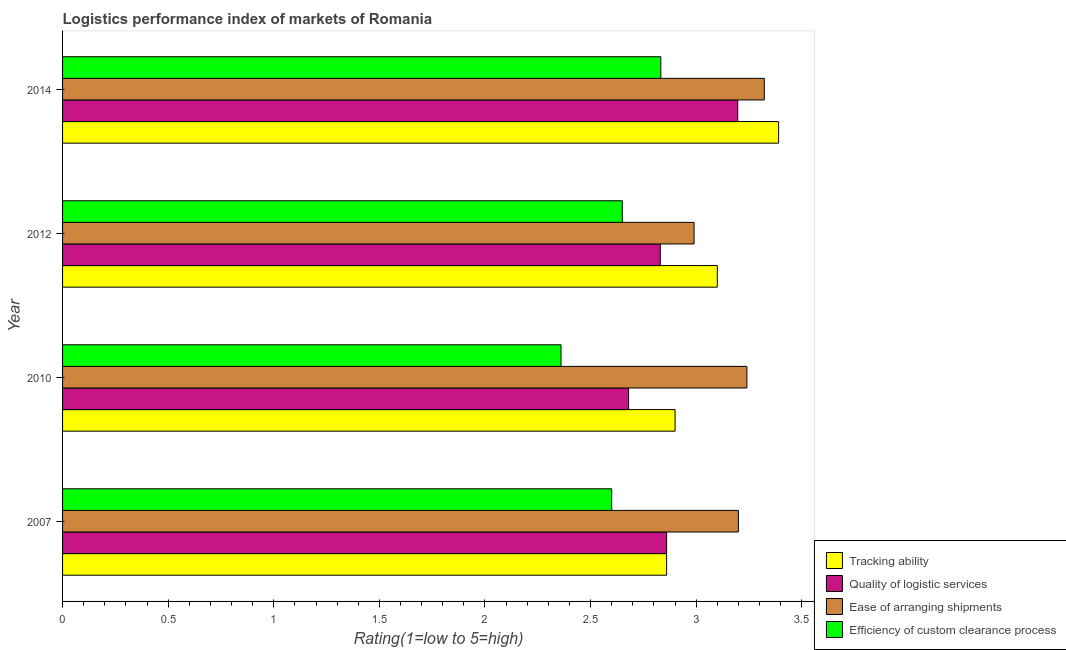Are the number of bars on each tick of the Y-axis equal?
Make the answer very short. Yes. How many bars are there on the 3rd tick from the top?
Make the answer very short. 4. In how many cases, is the number of bars for a given year not equal to the number of legend labels?
Offer a very short reply. 0. What is the lpi rating of quality of logistic services in 2010?
Keep it short and to the point. 2.68. Across all years, what is the maximum lpi rating of quality of logistic services?
Your answer should be very brief. 3.2. Across all years, what is the minimum lpi rating of efficiency of custom clearance process?
Provide a succinct answer. 2.36. In which year was the lpi rating of ease of arranging shipments maximum?
Your answer should be compact. 2014. In which year was the lpi rating of ease of arranging shipments minimum?
Offer a very short reply. 2012. What is the total lpi rating of tracking ability in the graph?
Provide a succinct answer. 12.25. What is the difference between the lpi rating of tracking ability in 2010 and that in 2012?
Your answer should be compact. -0.2. What is the difference between the lpi rating of tracking ability in 2010 and the lpi rating of quality of logistic services in 2007?
Offer a very short reply. 0.04. What is the average lpi rating of ease of arranging shipments per year?
Your answer should be compact. 3.19. In the year 2007, what is the difference between the lpi rating of ease of arranging shipments and lpi rating of efficiency of custom clearance process?
Offer a terse response. 0.6. What is the ratio of the lpi rating of efficiency of custom clearance process in 2007 to that in 2012?
Keep it short and to the point. 0.98. Is the lpi rating of efficiency of custom clearance process in 2007 less than that in 2012?
Your answer should be very brief. Yes. Is the difference between the lpi rating of efficiency of custom clearance process in 2012 and 2014 greater than the difference between the lpi rating of tracking ability in 2012 and 2014?
Ensure brevity in your answer.  Yes. What is the difference between the highest and the second highest lpi rating of ease of arranging shipments?
Make the answer very short. 0.08. What is the difference between the highest and the lowest lpi rating of efficiency of custom clearance process?
Your response must be concise. 0.47. What does the 2nd bar from the top in 2007 represents?
Ensure brevity in your answer.  Ease of arranging shipments. What does the 1st bar from the bottom in 2007 represents?
Provide a short and direct response. Tracking ability. How many bars are there?
Your answer should be very brief. 16. What is the difference between two consecutive major ticks on the X-axis?
Provide a short and direct response. 0.5. Does the graph contain any zero values?
Your answer should be compact. No. Does the graph contain grids?
Offer a very short reply. No. How many legend labels are there?
Offer a terse response. 4. How are the legend labels stacked?
Give a very brief answer. Vertical. What is the title of the graph?
Make the answer very short. Logistics performance index of markets of Romania. What is the label or title of the X-axis?
Your response must be concise. Rating(1=low to 5=high). What is the Rating(1=low to 5=high) in Tracking ability in 2007?
Your answer should be compact. 2.86. What is the Rating(1=low to 5=high) in Quality of logistic services in 2007?
Your answer should be very brief. 2.86. What is the Rating(1=low to 5=high) of Tracking ability in 2010?
Keep it short and to the point. 2.9. What is the Rating(1=low to 5=high) in Quality of logistic services in 2010?
Provide a short and direct response. 2.68. What is the Rating(1=low to 5=high) in Ease of arranging shipments in 2010?
Offer a terse response. 3.24. What is the Rating(1=low to 5=high) in Efficiency of custom clearance process in 2010?
Your answer should be compact. 2.36. What is the Rating(1=low to 5=high) in Quality of logistic services in 2012?
Offer a very short reply. 2.83. What is the Rating(1=low to 5=high) in Ease of arranging shipments in 2012?
Your answer should be very brief. 2.99. What is the Rating(1=low to 5=high) of Efficiency of custom clearance process in 2012?
Give a very brief answer. 2.65. What is the Rating(1=low to 5=high) of Tracking ability in 2014?
Your answer should be very brief. 3.39. What is the Rating(1=low to 5=high) in Quality of logistic services in 2014?
Make the answer very short. 3.2. What is the Rating(1=low to 5=high) of Ease of arranging shipments in 2014?
Make the answer very short. 3.32. What is the Rating(1=low to 5=high) of Efficiency of custom clearance process in 2014?
Give a very brief answer. 2.83. Across all years, what is the maximum Rating(1=low to 5=high) in Tracking ability?
Give a very brief answer. 3.39. Across all years, what is the maximum Rating(1=low to 5=high) of Quality of logistic services?
Your answer should be very brief. 3.2. Across all years, what is the maximum Rating(1=low to 5=high) of Ease of arranging shipments?
Keep it short and to the point. 3.32. Across all years, what is the maximum Rating(1=low to 5=high) of Efficiency of custom clearance process?
Your answer should be very brief. 2.83. Across all years, what is the minimum Rating(1=low to 5=high) of Tracking ability?
Ensure brevity in your answer.  2.86. Across all years, what is the minimum Rating(1=low to 5=high) of Quality of logistic services?
Provide a succinct answer. 2.68. Across all years, what is the minimum Rating(1=low to 5=high) in Ease of arranging shipments?
Keep it short and to the point. 2.99. Across all years, what is the minimum Rating(1=low to 5=high) of Efficiency of custom clearance process?
Provide a succinct answer. 2.36. What is the total Rating(1=low to 5=high) in Tracking ability in the graph?
Offer a terse response. 12.25. What is the total Rating(1=low to 5=high) of Quality of logistic services in the graph?
Keep it short and to the point. 11.57. What is the total Rating(1=low to 5=high) of Ease of arranging shipments in the graph?
Provide a succinct answer. 12.75. What is the total Rating(1=low to 5=high) of Efficiency of custom clearance process in the graph?
Ensure brevity in your answer.  10.44. What is the difference between the Rating(1=low to 5=high) of Tracking ability in 2007 and that in 2010?
Make the answer very short. -0.04. What is the difference between the Rating(1=low to 5=high) of Quality of logistic services in 2007 and that in 2010?
Keep it short and to the point. 0.18. What is the difference between the Rating(1=low to 5=high) in Ease of arranging shipments in 2007 and that in 2010?
Ensure brevity in your answer.  -0.04. What is the difference between the Rating(1=low to 5=high) in Efficiency of custom clearance process in 2007 and that in 2010?
Make the answer very short. 0.24. What is the difference between the Rating(1=low to 5=high) of Tracking ability in 2007 and that in 2012?
Give a very brief answer. -0.24. What is the difference between the Rating(1=low to 5=high) in Quality of logistic services in 2007 and that in 2012?
Offer a terse response. 0.03. What is the difference between the Rating(1=low to 5=high) in Ease of arranging shipments in 2007 and that in 2012?
Offer a terse response. 0.21. What is the difference between the Rating(1=low to 5=high) of Tracking ability in 2007 and that in 2014?
Ensure brevity in your answer.  -0.53. What is the difference between the Rating(1=low to 5=high) in Quality of logistic services in 2007 and that in 2014?
Keep it short and to the point. -0.34. What is the difference between the Rating(1=low to 5=high) of Ease of arranging shipments in 2007 and that in 2014?
Keep it short and to the point. -0.12. What is the difference between the Rating(1=low to 5=high) in Efficiency of custom clearance process in 2007 and that in 2014?
Offer a terse response. -0.23. What is the difference between the Rating(1=low to 5=high) in Tracking ability in 2010 and that in 2012?
Your response must be concise. -0.2. What is the difference between the Rating(1=low to 5=high) of Quality of logistic services in 2010 and that in 2012?
Your answer should be compact. -0.15. What is the difference between the Rating(1=low to 5=high) in Ease of arranging shipments in 2010 and that in 2012?
Ensure brevity in your answer.  0.25. What is the difference between the Rating(1=low to 5=high) in Efficiency of custom clearance process in 2010 and that in 2012?
Offer a very short reply. -0.29. What is the difference between the Rating(1=low to 5=high) in Tracking ability in 2010 and that in 2014?
Ensure brevity in your answer.  -0.49. What is the difference between the Rating(1=low to 5=high) of Quality of logistic services in 2010 and that in 2014?
Your answer should be very brief. -0.52. What is the difference between the Rating(1=low to 5=high) in Ease of arranging shipments in 2010 and that in 2014?
Keep it short and to the point. -0.08. What is the difference between the Rating(1=low to 5=high) of Efficiency of custom clearance process in 2010 and that in 2014?
Your response must be concise. -0.47. What is the difference between the Rating(1=low to 5=high) in Tracking ability in 2012 and that in 2014?
Provide a short and direct response. -0.29. What is the difference between the Rating(1=low to 5=high) of Quality of logistic services in 2012 and that in 2014?
Offer a very short reply. -0.37. What is the difference between the Rating(1=low to 5=high) of Ease of arranging shipments in 2012 and that in 2014?
Make the answer very short. -0.33. What is the difference between the Rating(1=low to 5=high) of Efficiency of custom clearance process in 2012 and that in 2014?
Offer a very short reply. -0.18. What is the difference between the Rating(1=low to 5=high) of Tracking ability in 2007 and the Rating(1=low to 5=high) of Quality of logistic services in 2010?
Give a very brief answer. 0.18. What is the difference between the Rating(1=low to 5=high) of Tracking ability in 2007 and the Rating(1=low to 5=high) of Ease of arranging shipments in 2010?
Offer a terse response. -0.38. What is the difference between the Rating(1=low to 5=high) of Quality of logistic services in 2007 and the Rating(1=low to 5=high) of Ease of arranging shipments in 2010?
Give a very brief answer. -0.38. What is the difference between the Rating(1=low to 5=high) in Quality of logistic services in 2007 and the Rating(1=low to 5=high) in Efficiency of custom clearance process in 2010?
Give a very brief answer. 0.5. What is the difference between the Rating(1=low to 5=high) in Ease of arranging shipments in 2007 and the Rating(1=low to 5=high) in Efficiency of custom clearance process in 2010?
Provide a short and direct response. 0.84. What is the difference between the Rating(1=low to 5=high) of Tracking ability in 2007 and the Rating(1=low to 5=high) of Ease of arranging shipments in 2012?
Ensure brevity in your answer.  -0.13. What is the difference between the Rating(1=low to 5=high) of Tracking ability in 2007 and the Rating(1=low to 5=high) of Efficiency of custom clearance process in 2012?
Make the answer very short. 0.21. What is the difference between the Rating(1=low to 5=high) in Quality of logistic services in 2007 and the Rating(1=low to 5=high) in Ease of arranging shipments in 2012?
Provide a short and direct response. -0.13. What is the difference between the Rating(1=low to 5=high) in Quality of logistic services in 2007 and the Rating(1=low to 5=high) in Efficiency of custom clearance process in 2012?
Your response must be concise. 0.21. What is the difference between the Rating(1=low to 5=high) in Ease of arranging shipments in 2007 and the Rating(1=low to 5=high) in Efficiency of custom clearance process in 2012?
Your answer should be very brief. 0.55. What is the difference between the Rating(1=low to 5=high) of Tracking ability in 2007 and the Rating(1=low to 5=high) of Quality of logistic services in 2014?
Offer a very short reply. -0.34. What is the difference between the Rating(1=low to 5=high) of Tracking ability in 2007 and the Rating(1=low to 5=high) of Ease of arranging shipments in 2014?
Keep it short and to the point. -0.46. What is the difference between the Rating(1=low to 5=high) of Tracking ability in 2007 and the Rating(1=low to 5=high) of Efficiency of custom clearance process in 2014?
Give a very brief answer. 0.03. What is the difference between the Rating(1=low to 5=high) of Quality of logistic services in 2007 and the Rating(1=low to 5=high) of Ease of arranging shipments in 2014?
Ensure brevity in your answer.  -0.46. What is the difference between the Rating(1=low to 5=high) in Quality of logistic services in 2007 and the Rating(1=low to 5=high) in Efficiency of custom clearance process in 2014?
Make the answer very short. 0.03. What is the difference between the Rating(1=low to 5=high) of Ease of arranging shipments in 2007 and the Rating(1=low to 5=high) of Efficiency of custom clearance process in 2014?
Your answer should be compact. 0.37. What is the difference between the Rating(1=low to 5=high) of Tracking ability in 2010 and the Rating(1=low to 5=high) of Quality of logistic services in 2012?
Make the answer very short. 0.07. What is the difference between the Rating(1=low to 5=high) of Tracking ability in 2010 and the Rating(1=low to 5=high) of Ease of arranging shipments in 2012?
Provide a short and direct response. -0.09. What is the difference between the Rating(1=low to 5=high) of Quality of logistic services in 2010 and the Rating(1=low to 5=high) of Ease of arranging shipments in 2012?
Give a very brief answer. -0.31. What is the difference between the Rating(1=low to 5=high) in Ease of arranging shipments in 2010 and the Rating(1=low to 5=high) in Efficiency of custom clearance process in 2012?
Your answer should be compact. 0.59. What is the difference between the Rating(1=low to 5=high) in Tracking ability in 2010 and the Rating(1=low to 5=high) in Quality of logistic services in 2014?
Your answer should be compact. -0.3. What is the difference between the Rating(1=low to 5=high) in Tracking ability in 2010 and the Rating(1=low to 5=high) in Ease of arranging shipments in 2014?
Make the answer very short. -0.42. What is the difference between the Rating(1=low to 5=high) in Tracking ability in 2010 and the Rating(1=low to 5=high) in Efficiency of custom clearance process in 2014?
Offer a very short reply. 0.07. What is the difference between the Rating(1=low to 5=high) in Quality of logistic services in 2010 and the Rating(1=low to 5=high) in Ease of arranging shipments in 2014?
Give a very brief answer. -0.64. What is the difference between the Rating(1=low to 5=high) of Quality of logistic services in 2010 and the Rating(1=low to 5=high) of Efficiency of custom clearance process in 2014?
Your answer should be very brief. -0.15. What is the difference between the Rating(1=low to 5=high) in Ease of arranging shipments in 2010 and the Rating(1=low to 5=high) in Efficiency of custom clearance process in 2014?
Your answer should be very brief. 0.41. What is the difference between the Rating(1=low to 5=high) of Tracking ability in 2012 and the Rating(1=low to 5=high) of Quality of logistic services in 2014?
Offer a very short reply. -0.1. What is the difference between the Rating(1=low to 5=high) of Tracking ability in 2012 and the Rating(1=low to 5=high) of Ease of arranging shipments in 2014?
Provide a short and direct response. -0.22. What is the difference between the Rating(1=low to 5=high) of Tracking ability in 2012 and the Rating(1=low to 5=high) of Efficiency of custom clearance process in 2014?
Make the answer very short. 0.27. What is the difference between the Rating(1=low to 5=high) of Quality of logistic services in 2012 and the Rating(1=low to 5=high) of Ease of arranging shipments in 2014?
Ensure brevity in your answer.  -0.49. What is the difference between the Rating(1=low to 5=high) of Quality of logistic services in 2012 and the Rating(1=low to 5=high) of Efficiency of custom clearance process in 2014?
Your answer should be very brief. -0. What is the difference between the Rating(1=low to 5=high) in Ease of arranging shipments in 2012 and the Rating(1=low to 5=high) in Efficiency of custom clearance process in 2014?
Give a very brief answer. 0.16. What is the average Rating(1=low to 5=high) in Tracking ability per year?
Offer a very short reply. 3.06. What is the average Rating(1=low to 5=high) in Quality of logistic services per year?
Your response must be concise. 2.89. What is the average Rating(1=low to 5=high) of Ease of arranging shipments per year?
Give a very brief answer. 3.19. What is the average Rating(1=low to 5=high) of Efficiency of custom clearance process per year?
Give a very brief answer. 2.61. In the year 2007, what is the difference between the Rating(1=low to 5=high) in Tracking ability and Rating(1=low to 5=high) in Ease of arranging shipments?
Keep it short and to the point. -0.34. In the year 2007, what is the difference between the Rating(1=low to 5=high) of Tracking ability and Rating(1=low to 5=high) of Efficiency of custom clearance process?
Offer a very short reply. 0.26. In the year 2007, what is the difference between the Rating(1=low to 5=high) of Quality of logistic services and Rating(1=low to 5=high) of Ease of arranging shipments?
Provide a short and direct response. -0.34. In the year 2007, what is the difference between the Rating(1=low to 5=high) in Quality of logistic services and Rating(1=low to 5=high) in Efficiency of custom clearance process?
Ensure brevity in your answer.  0.26. In the year 2007, what is the difference between the Rating(1=low to 5=high) of Ease of arranging shipments and Rating(1=low to 5=high) of Efficiency of custom clearance process?
Your response must be concise. 0.6. In the year 2010, what is the difference between the Rating(1=low to 5=high) in Tracking ability and Rating(1=low to 5=high) in Quality of logistic services?
Provide a succinct answer. 0.22. In the year 2010, what is the difference between the Rating(1=low to 5=high) of Tracking ability and Rating(1=low to 5=high) of Ease of arranging shipments?
Give a very brief answer. -0.34. In the year 2010, what is the difference between the Rating(1=low to 5=high) in Tracking ability and Rating(1=low to 5=high) in Efficiency of custom clearance process?
Your answer should be very brief. 0.54. In the year 2010, what is the difference between the Rating(1=low to 5=high) in Quality of logistic services and Rating(1=low to 5=high) in Ease of arranging shipments?
Provide a succinct answer. -0.56. In the year 2010, what is the difference between the Rating(1=low to 5=high) of Quality of logistic services and Rating(1=low to 5=high) of Efficiency of custom clearance process?
Offer a very short reply. 0.32. In the year 2012, what is the difference between the Rating(1=low to 5=high) in Tracking ability and Rating(1=low to 5=high) in Quality of logistic services?
Give a very brief answer. 0.27. In the year 2012, what is the difference between the Rating(1=low to 5=high) of Tracking ability and Rating(1=low to 5=high) of Ease of arranging shipments?
Your answer should be very brief. 0.11. In the year 2012, what is the difference between the Rating(1=low to 5=high) of Tracking ability and Rating(1=low to 5=high) of Efficiency of custom clearance process?
Your response must be concise. 0.45. In the year 2012, what is the difference between the Rating(1=low to 5=high) of Quality of logistic services and Rating(1=low to 5=high) of Ease of arranging shipments?
Ensure brevity in your answer.  -0.16. In the year 2012, what is the difference between the Rating(1=low to 5=high) of Quality of logistic services and Rating(1=low to 5=high) of Efficiency of custom clearance process?
Keep it short and to the point. 0.18. In the year 2012, what is the difference between the Rating(1=low to 5=high) in Ease of arranging shipments and Rating(1=low to 5=high) in Efficiency of custom clearance process?
Keep it short and to the point. 0.34. In the year 2014, what is the difference between the Rating(1=low to 5=high) of Tracking ability and Rating(1=low to 5=high) of Quality of logistic services?
Your answer should be compact. 0.19. In the year 2014, what is the difference between the Rating(1=low to 5=high) of Tracking ability and Rating(1=low to 5=high) of Ease of arranging shipments?
Ensure brevity in your answer.  0.07. In the year 2014, what is the difference between the Rating(1=low to 5=high) of Tracking ability and Rating(1=low to 5=high) of Efficiency of custom clearance process?
Offer a very short reply. 0.56. In the year 2014, what is the difference between the Rating(1=low to 5=high) in Quality of logistic services and Rating(1=low to 5=high) in Ease of arranging shipments?
Your answer should be very brief. -0.13. In the year 2014, what is the difference between the Rating(1=low to 5=high) in Quality of logistic services and Rating(1=low to 5=high) in Efficiency of custom clearance process?
Your answer should be very brief. 0.36. In the year 2014, what is the difference between the Rating(1=low to 5=high) of Ease of arranging shipments and Rating(1=low to 5=high) of Efficiency of custom clearance process?
Ensure brevity in your answer.  0.49. What is the ratio of the Rating(1=low to 5=high) of Tracking ability in 2007 to that in 2010?
Provide a succinct answer. 0.99. What is the ratio of the Rating(1=low to 5=high) in Quality of logistic services in 2007 to that in 2010?
Provide a short and direct response. 1.07. What is the ratio of the Rating(1=low to 5=high) of Efficiency of custom clearance process in 2007 to that in 2010?
Provide a succinct answer. 1.1. What is the ratio of the Rating(1=low to 5=high) in Tracking ability in 2007 to that in 2012?
Provide a succinct answer. 0.92. What is the ratio of the Rating(1=low to 5=high) in Quality of logistic services in 2007 to that in 2012?
Your response must be concise. 1.01. What is the ratio of the Rating(1=low to 5=high) in Ease of arranging shipments in 2007 to that in 2012?
Ensure brevity in your answer.  1.07. What is the ratio of the Rating(1=low to 5=high) of Efficiency of custom clearance process in 2007 to that in 2012?
Make the answer very short. 0.98. What is the ratio of the Rating(1=low to 5=high) in Tracking ability in 2007 to that in 2014?
Provide a short and direct response. 0.84. What is the ratio of the Rating(1=low to 5=high) of Quality of logistic services in 2007 to that in 2014?
Ensure brevity in your answer.  0.89. What is the ratio of the Rating(1=low to 5=high) of Ease of arranging shipments in 2007 to that in 2014?
Your answer should be very brief. 0.96. What is the ratio of the Rating(1=low to 5=high) of Efficiency of custom clearance process in 2007 to that in 2014?
Ensure brevity in your answer.  0.92. What is the ratio of the Rating(1=low to 5=high) of Tracking ability in 2010 to that in 2012?
Your answer should be compact. 0.94. What is the ratio of the Rating(1=low to 5=high) of Quality of logistic services in 2010 to that in 2012?
Ensure brevity in your answer.  0.95. What is the ratio of the Rating(1=low to 5=high) in Ease of arranging shipments in 2010 to that in 2012?
Your answer should be very brief. 1.08. What is the ratio of the Rating(1=low to 5=high) in Efficiency of custom clearance process in 2010 to that in 2012?
Ensure brevity in your answer.  0.89. What is the ratio of the Rating(1=low to 5=high) in Tracking ability in 2010 to that in 2014?
Your answer should be very brief. 0.86. What is the ratio of the Rating(1=low to 5=high) of Quality of logistic services in 2010 to that in 2014?
Your response must be concise. 0.84. What is the ratio of the Rating(1=low to 5=high) in Ease of arranging shipments in 2010 to that in 2014?
Your answer should be very brief. 0.98. What is the ratio of the Rating(1=low to 5=high) of Efficiency of custom clearance process in 2010 to that in 2014?
Make the answer very short. 0.83. What is the ratio of the Rating(1=low to 5=high) of Tracking ability in 2012 to that in 2014?
Provide a succinct answer. 0.91. What is the ratio of the Rating(1=low to 5=high) in Quality of logistic services in 2012 to that in 2014?
Offer a very short reply. 0.89. What is the ratio of the Rating(1=low to 5=high) in Ease of arranging shipments in 2012 to that in 2014?
Your answer should be very brief. 0.9. What is the ratio of the Rating(1=low to 5=high) of Efficiency of custom clearance process in 2012 to that in 2014?
Provide a short and direct response. 0.94. What is the difference between the highest and the second highest Rating(1=low to 5=high) in Tracking ability?
Your answer should be very brief. 0.29. What is the difference between the highest and the second highest Rating(1=low to 5=high) of Quality of logistic services?
Ensure brevity in your answer.  0.34. What is the difference between the highest and the second highest Rating(1=low to 5=high) in Ease of arranging shipments?
Give a very brief answer. 0.08. What is the difference between the highest and the second highest Rating(1=low to 5=high) of Efficiency of custom clearance process?
Provide a succinct answer. 0.18. What is the difference between the highest and the lowest Rating(1=low to 5=high) of Tracking ability?
Provide a short and direct response. 0.53. What is the difference between the highest and the lowest Rating(1=low to 5=high) of Quality of logistic services?
Offer a terse response. 0.52. What is the difference between the highest and the lowest Rating(1=low to 5=high) of Ease of arranging shipments?
Make the answer very short. 0.33. What is the difference between the highest and the lowest Rating(1=low to 5=high) of Efficiency of custom clearance process?
Offer a very short reply. 0.47. 